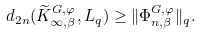Convert formula to latex. <formula><loc_0><loc_0><loc_500><loc_500>d _ { 2 n } ( \widetilde { K } ^ { G , \varphi } _ { \infty , \beta } , L _ { q } ) \geq \| \Phi _ { n , \beta } ^ { G , \varphi } \| _ { q } .</formula> 